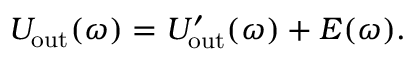<formula> <loc_0><loc_0><loc_500><loc_500>U _ { o u t } ( \omega ) = U _ { o u t } ^ { \prime } ( \omega ) + E ( \omega ) .</formula> 